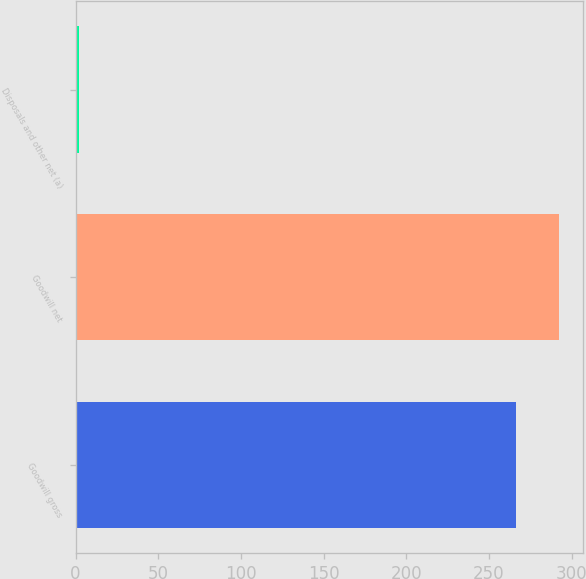Convert chart to OTSL. <chart><loc_0><loc_0><loc_500><loc_500><bar_chart><fcel>Goodwill gross<fcel>Goodwill net<fcel>Disposals and other net (a)<nl><fcel>266<fcel>292.4<fcel>2<nl></chart> 